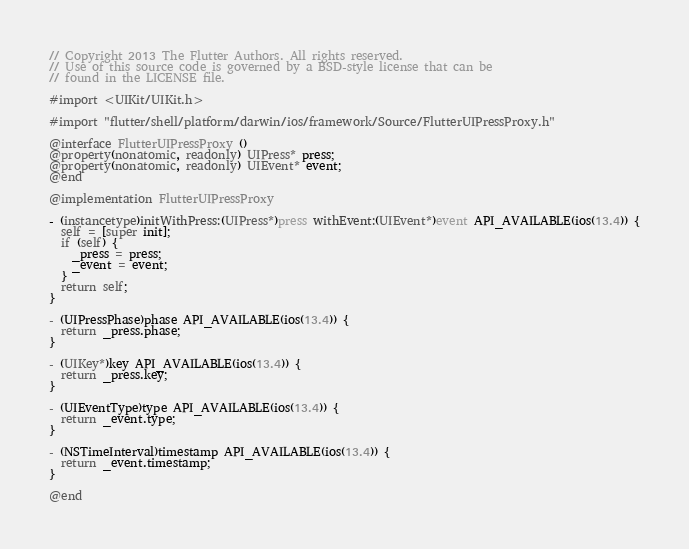<code> <loc_0><loc_0><loc_500><loc_500><_ObjectiveC_>// Copyright 2013 The Flutter Authors. All rights reserved.
// Use of this source code is governed by a BSD-style license that can be
// found in the LICENSE file.

#import <UIKit/UIKit.h>

#import "flutter/shell/platform/darwin/ios/framework/Source/FlutterUIPressProxy.h"

@interface FlutterUIPressProxy ()
@property(nonatomic, readonly) UIPress* press;
@property(nonatomic, readonly) UIEvent* event;
@end

@implementation FlutterUIPressProxy

- (instancetype)initWithPress:(UIPress*)press withEvent:(UIEvent*)event API_AVAILABLE(ios(13.4)) {
  self = [super init];
  if (self) {
    _press = press;
    _event = event;
  }
  return self;
}

- (UIPressPhase)phase API_AVAILABLE(ios(13.4)) {
  return _press.phase;
}

- (UIKey*)key API_AVAILABLE(ios(13.4)) {
  return _press.key;
}

- (UIEventType)type API_AVAILABLE(ios(13.4)) {
  return _event.type;
}

- (NSTimeInterval)timestamp API_AVAILABLE(ios(13.4)) {
  return _event.timestamp;
}

@end
</code> 